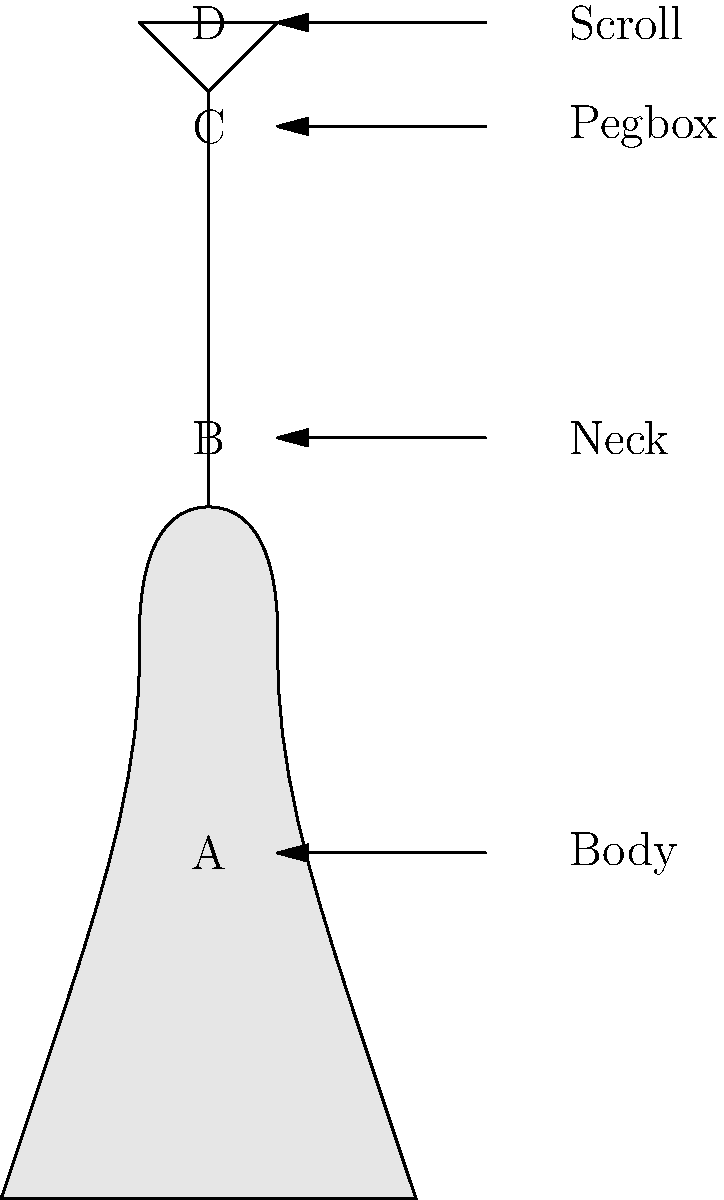As a retired violin teacher, you're helping a new student understand the parts of a violin. Using the labeled diagram, identify the part of the violin indicated by letter C. To answer this question, let's analyze the diagram step-by-step:

1. The diagram shows a simplified outline of a violin with four labeled parts: A, B, C, and D.

2. Each label corresponds to a specific part of the violin, indicated by arrows pointing to different areas of the instrument.

3. Starting from the bottom:
   - A points to the main body of the violin
   - B points to the long, narrow section above the body
   - C points to a small section near the top of the instrument
   - D points to the curved part at the very top

4. From your experience as a violin teacher, you know that:
   - The main body is called the "Body"
   - The long, narrow section is the "Neck"
   - The small section near the top where the tuning pegs are located is the "Pegbox"
   - The curved part at the very top is called the "Scroll"

5. Looking at the diagram, we can see that C is pointing to the small section near the top, just below the scroll.

6. Matching this with our knowledge of violin parts, we can conclude that C is pointing to the Pegbox.
Answer: Pegbox 